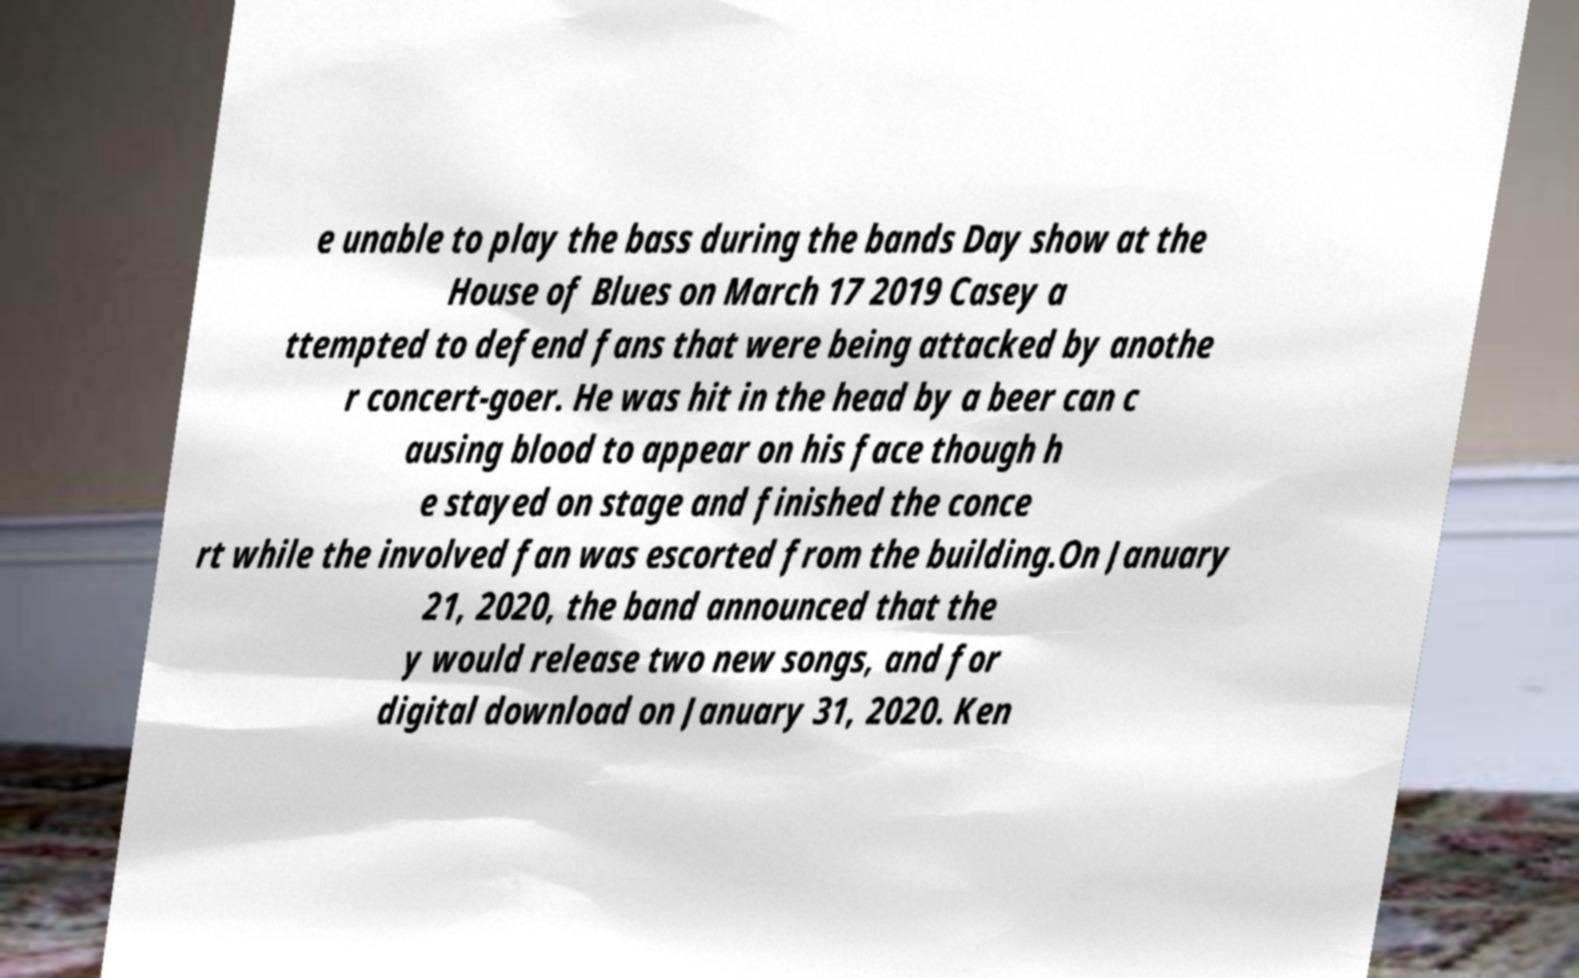Could you assist in decoding the text presented in this image and type it out clearly? e unable to play the bass during the bands Day show at the House of Blues on March 17 2019 Casey a ttempted to defend fans that were being attacked by anothe r concert-goer. He was hit in the head by a beer can c ausing blood to appear on his face though h e stayed on stage and finished the conce rt while the involved fan was escorted from the building.On January 21, 2020, the band announced that the y would release two new songs, and for digital download on January 31, 2020. Ken 